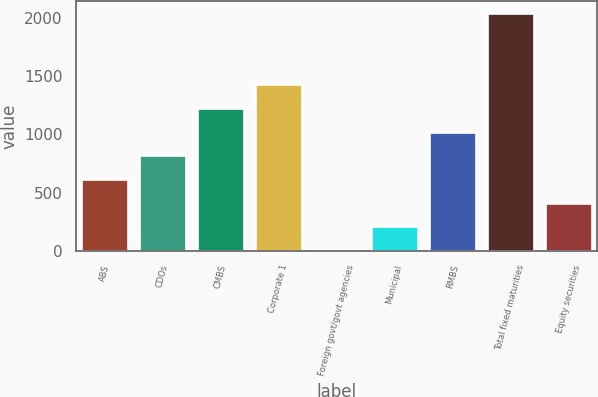<chart> <loc_0><loc_0><loc_500><loc_500><bar_chart><fcel>ABS<fcel>CDOs<fcel>CMBS<fcel>Corporate 1<fcel>Foreign govt/govt agencies<fcel>Municipal<fcel>RMBS<fcel>Total fixed maturities<fcel>Equity securities<nl><fcel>616<fcel>820<fcel>1228<fcel>1432<fcel>4<fcel>208<fcel>1024<fcel>2044<fcel>412<nl></chart> 